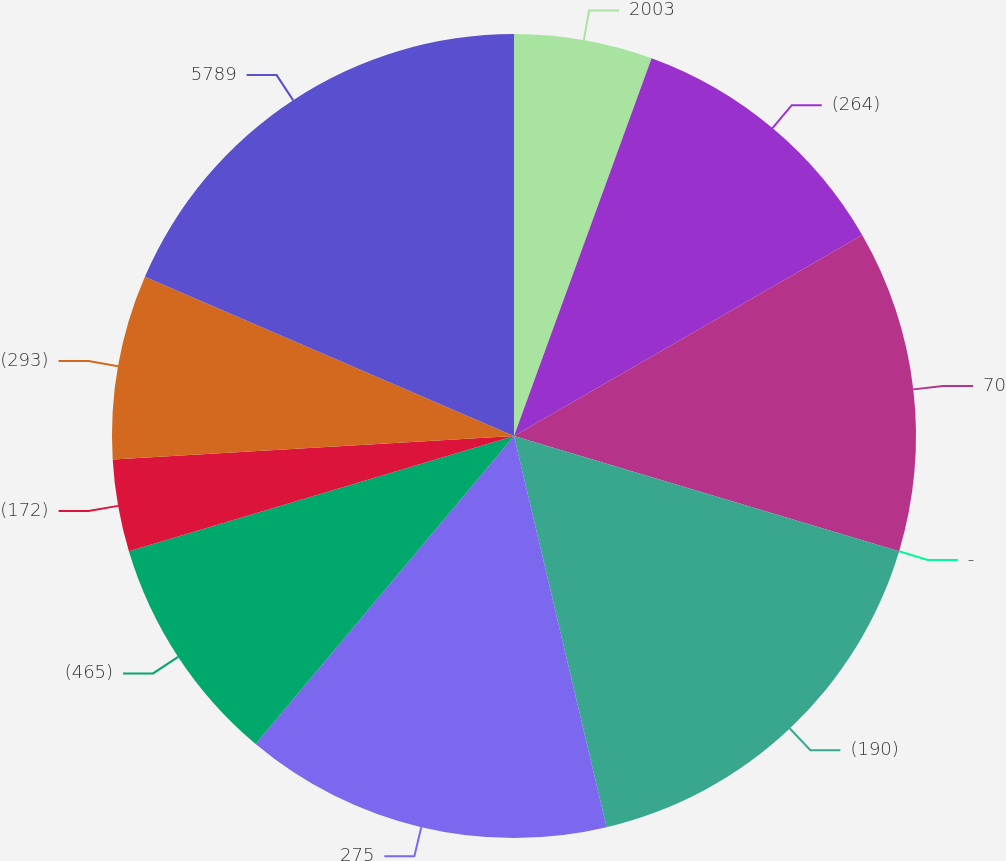Convert chart. <chart><loc_0><loc_0><loc_500><loc_500><pie_chart><fcel>2003<fcel>(264)<fcel>70<fcel>-<fcel>(190)<fcel>275<fcel>(465)<fcel>(172)<fcel>(293)<fcel>5789<nl><fcel>5.56%<fcel>11.11%<fcel>12.96%<fcel>0.0%<fcel>16.67%<fcel>14.81%<fcel>9.26%<fcel>3.7%<fcel>7.41%<fcel>18.52%<nl></chart> 